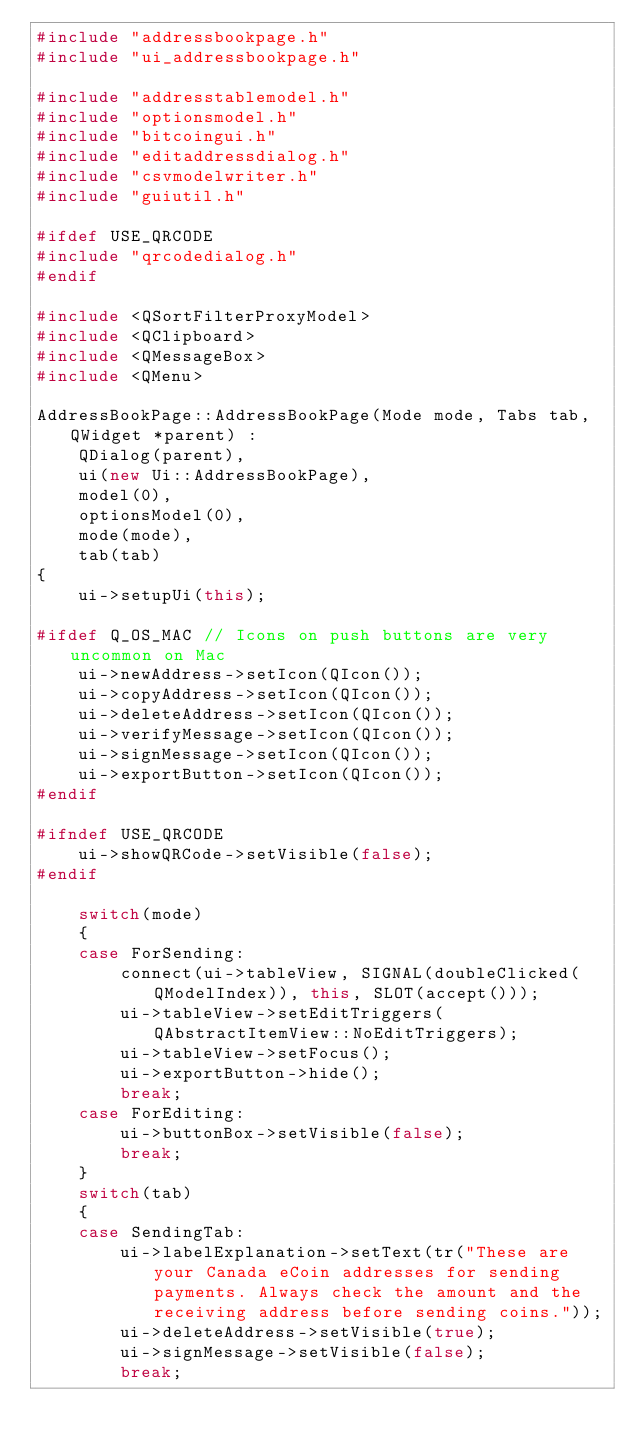Convert code to text. <code><loc_0><loc_0><loc_500><loc_500><_C++_>#include "addressbookpage.h"
#include "ui_addressbookpage.h"

#include "addresstablemodel.h"
#include "optionsmodel.h"
#include "bitcoingui.h"
#include "editaddressdialog.h"
#include "csvmodelwriter.h"
#include "guiutil.h"

#ifdef USE_QRCODE
#include "qrcodedialog.h"
#endif

#include <QSortFilterProxyModel>
#include <QClipboard>
#include <QMessageBox>
#include <QMenu>

AddressBookPage::AddressBookPage(Mode mode, Tabs tab, QWidget *parent) :
    QDialog(parent),
    ui(new Ui::AddressBookPage),
    model(0),
    optionsModel(0),
    mode(mode),
    tab(tab)
{
    ui->setupUi(this);

#ifdef Q_OS_MAC // Icons on push buttons are very uncommon on Mac
    ui->newAddress->setIcon(QIcon());
    ui->copyAddress->setIcon(QIcon());
    ui->deleteAddress->setIcon(QIcon());
    ui->verifyMessage->setIcon(QIcon());
    ui->signMessage->setIcon(QIcon());
    ui->exportButton->setIcon(QIcon());
#endif

#ifndef USE_QRCODE
    ui->showQRCode->setVisible(false);
#endif

    switch(mode)
    {
    case ForSending:
        connect(ui->tableView, SIGNAL(doubleClicked(QModelIndex)), this, SLOT(accept()));
        ui->tableView->setEditTriggers(QAbstractItemView::NoEditTriggers);
        ui->tableView->setFocus();
        ui->exportButton->hide();
        break;
    case ForEditing:
        ui->buttonBox->setVisible(false);
        break;
    }
    switch(tab)
    {
    case SendingTab:
        ui->labelExplanation->setText(tr("These are your Canada eCoin addresses for sending payments. Always check the amount and the receiving address before sending coins."));
        ui->deleteAddress->setVisible(true);
        ui->signMessage->setVisible(false);
        break;</code> 